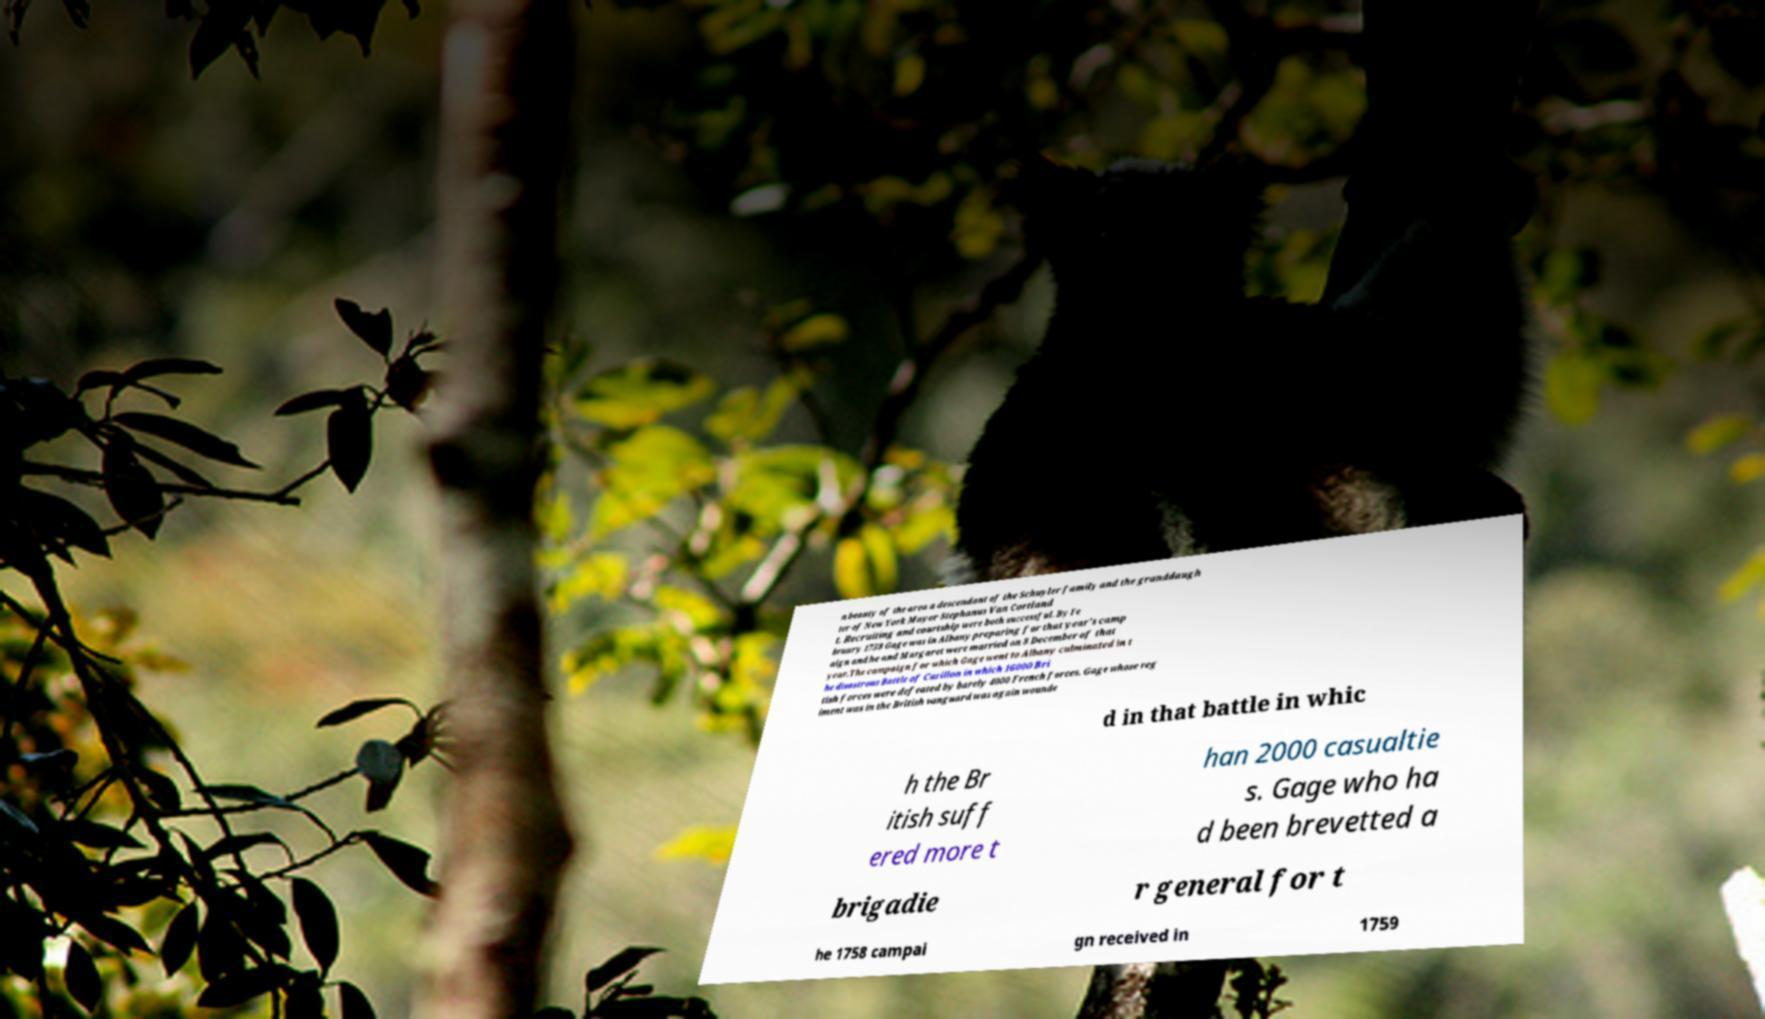What messages or text are displayed in this image? I need them in a readable, typed format. n beauty of the area a descendant of the Schuyler family and the granddaugh ter of New York Mayor Stephanus Van Cortland t. Recruiting and courtship were both successful. By Fe bruary 1758 Gage was in Albany preparing for that year's camp aign and he and Margaret were married on 8 December of that year.The campaign for which Gage went to Albany culminated in t he disastrous Battle of Carillon in which 16000 Bri tish forces were defeated by barely 4000 French forces. Gage whose reg iment was in the British vanguard was again wounde d in that battle in whic h the Br itish suff ered more t han 2000 casualtie s. Gage who ha d been brevetted a brigadie r general for t he 1758 campai gn received in 1759 